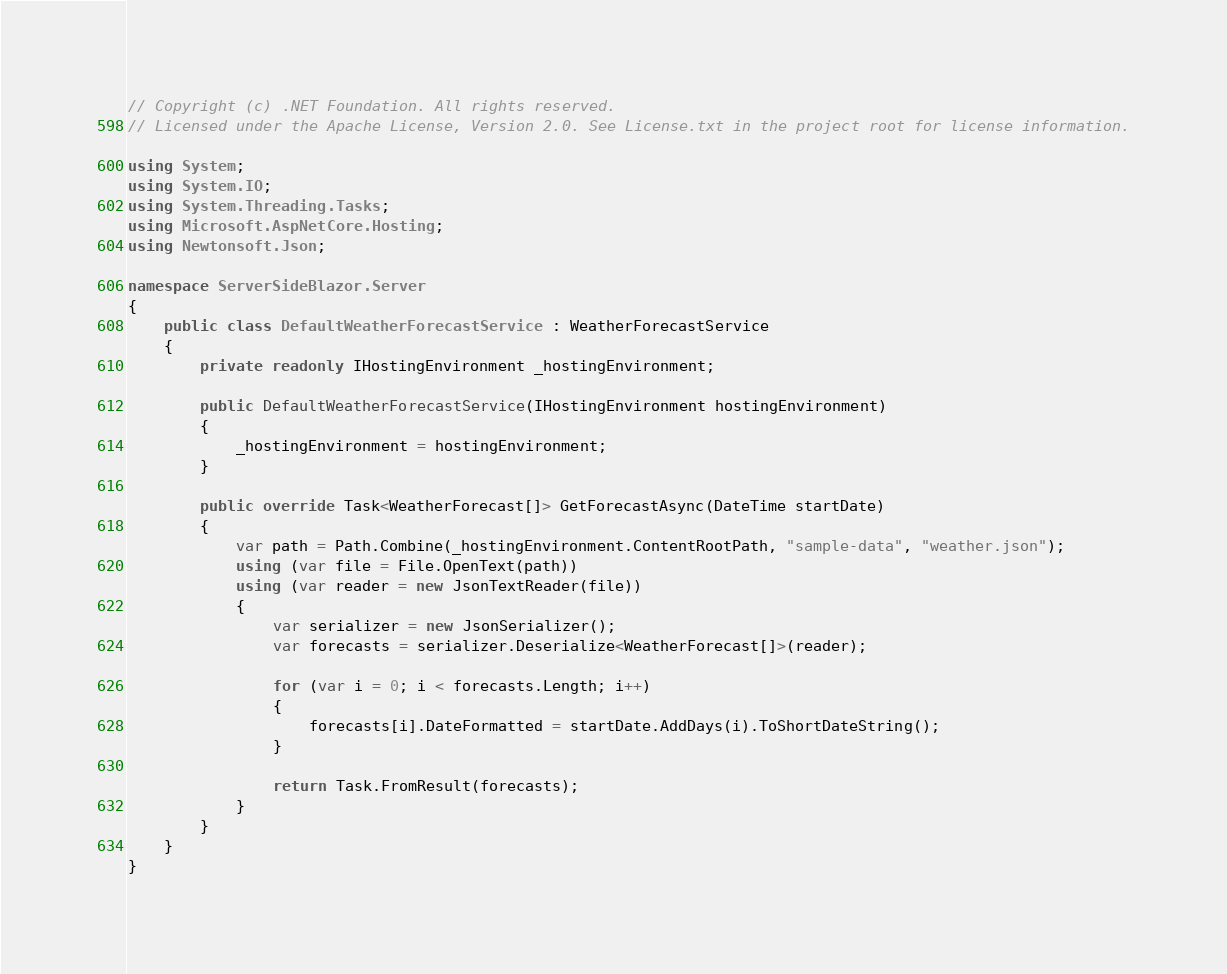<code> <loc_0><loc_0><loc_500><loc_500><_C#_>// Copyright (c) .NET Foundation. All rights reserved.
// Licensed under the Apache License, Version 2.0. See License.txt in the project root for license information.

using System;
using System.IO;
using System.Threading.Tasks;
using Microsoft.AspNetCore.Hosting;
using Newtonsoft.Json;

namespace ServerSideBlazor.Server
{
    public class DefaultWeatherForecastService : WeatherForecastService
    {
        private readonly IHostingEnvironment _hostingEnvironment;

        public DefaultWeatherForecastService(IHostingEnvironment hostingEnvironment)
        {
            _hostingEnvironment = hostingEnvironment;
        }

        public override Task<WeatherForecast[]> GetForecastAsync(DateTime startDate)
        {
            var path = Path.Combine(_hostingEnvironment.ContentRootPath, "sample-data", "weather.json");
            using (var file = File.OpenText(path))
            using (var reader = new JsonTextReader(file))
            {
                var serializer = new JsonSerializer();
                var forecasts = serializer.Deserialize<WeatherForecast[]>(reader);

                for (var i = 0; i < forecasts.Length; i++)
                {
                    forecasts[i].DateFormatted = startDate.AddDays(i).ToShortDateString();
                }

                return Task.FromResult(forecasts);
            }
        }
    }
}
</code> 